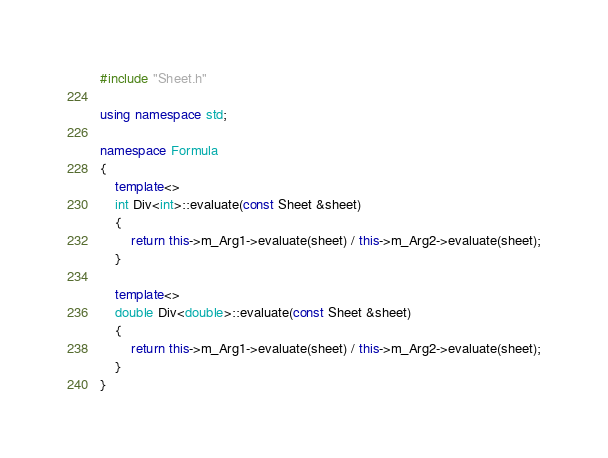<code> <loc_0><loc_0><loc_500><loc_500><_C++_>#include "Sheet.h"

using namespace std;

namespace Formula
{
    template<>
    int Div<int>::evaluate(const Sheet &sheet)
    {
        return this->m_Arg1->evaluate(sheet) / this->m_Arg2->evaluate(sheet);
    }

    template<>
    double Div<double>::evaluate(const Sheet &sheet)
    {
        return this->m_Arg1->evaluate(sheet) / this->m_Arg2->evaluate(sheet);
    }
}
</code> 